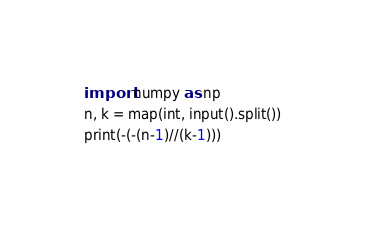Convert code to text. <code><loc_0><loc_0><loc_500><loc_500><_Python_>import numpy as np
n, k = map(int, input().split())
print(-(-(n-1)//(k-1)))</code> 